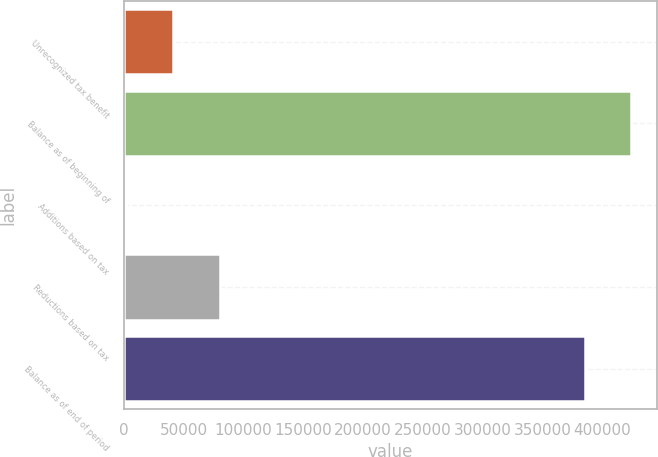<chart> <loc_0><loc_0><loc_500><loc_500><bar_chart><fcel>Unrecognized tax benefit<fcel>Balance as of beginning of<fcel>Additions based on tax<fcel>Reductions based on tax<fcel>Balance as of end of period<nl><fcel>40894.6<fcel>424619<fcel>1670<fcel>80119.2<fcel>385394<nl></chart> 